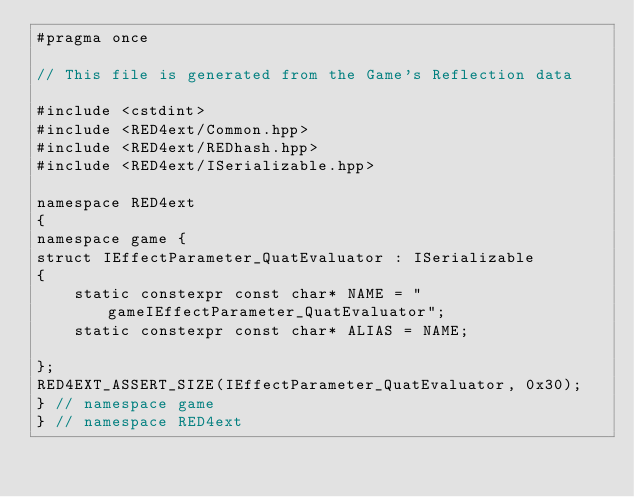<code> <loc_0><loc_0><loc_500><loc_500><_C++_>#pragma once

// This file is generated from the Game's Reflection data

#include <cstdint>
#include <RED4ext/Common.hpp>
#include <RED4ext/REDhash.hpp>
#include <RED4ext/ISerializable.hpp>

namespace RED4ext
{
namespace game { 
struct IEffectParameter_QuatEvaluator : ISerializable
{
    static constexpr const char* NAME = "gameIEffectParameter_QuatEvaluator";
    static constexpr const char* ALIAS = NAME;

};
RED4EXT_ASSERT_SIZE(IEffectParameter_QuatEvaluator, 0x30);
} // namespace game
} // namespace RED4ext
</code> 